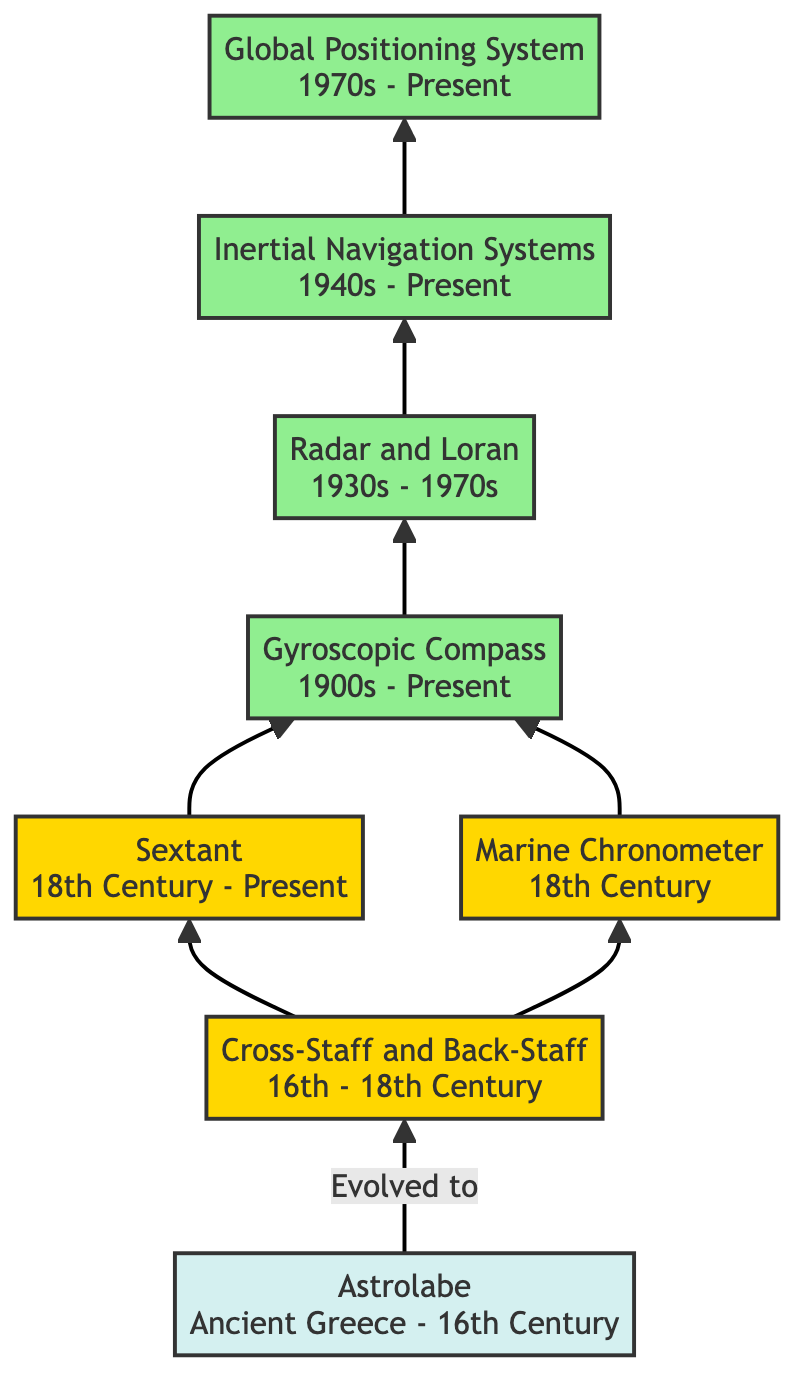What is the earliest navigation tool in the diagram? The first node in the flow chart is the Astrolabe, which dates back to Ancient Greece and is the earliest tool shown.
Answer: Astrolabe How many modern navigation tools are listed? The diagram lists four navigation tools that fall under the modern category: Gyroscopic Compass, Radar and Loran, Inertial Navigation Systems, and Global Positioning System.
Answer: Four What tool evolved from the Cross-Staff and Back-Staff? The diagram shows that the Sextant evolved from the Cross-Staff and Back-Staff, indicated by the arrow leading from the latter to the former.
Answer: Sextant What does the Marine Chronometer help determine? The Marine Chronometer is a high-precision timekeeping instrument used to determine longitude, according to its description in the diagram.
Answer: Longitude Which navigation tool comes directly before the Global Positioning System in the flow? The diagram indicates that Inertial Navigation Systems comes directly before the Global Positioning System, as shown by the upward arrow connecting the two.
Answer: Inertial Navigation Systems Which two tools were developed in the 18th Century? The diagram mentions both the Marine Chronometer and the Sextant were developed in the 18th Century, as both nodes indicate this period.
Answer: Marine Chronometer, Sextant What is the relationship between the Astrolabe and the Cross-Staff and Back-Staff? The flow chart shows a direct evolution relationship, as indicated by the arrow going from the Astrolabe to the Cross-Staff and Back-Staff, denoting that the latter evolved from the former.
Answer: Evolved to Which navigation tools were used for measuring angles of celestial bodies? The Cross-Staff and Back-Staff, and the Sextant are the tools specifically used for measuring angles of celestial bodies, as indicated in their descriptions.
Answer: Cross-Staff and Back-Staff, Sextant 